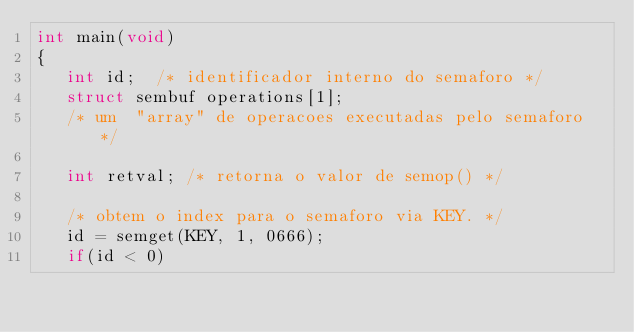<code> <loc_0><loc_0><loc_500><loc_500><_C_>int main(void)
{
   int id;  /* identificador interno do semaforo */
   struct sembuf operations[1];
   /* um  "array" de operacoes executadas pelo semaforo */

   int retval; /* retorna o valor de semop() */

   /* obtem o index para o semaforo via KEY. */
   id = semget(KEY, 1, 0666);
   if(id < 0)</code> 